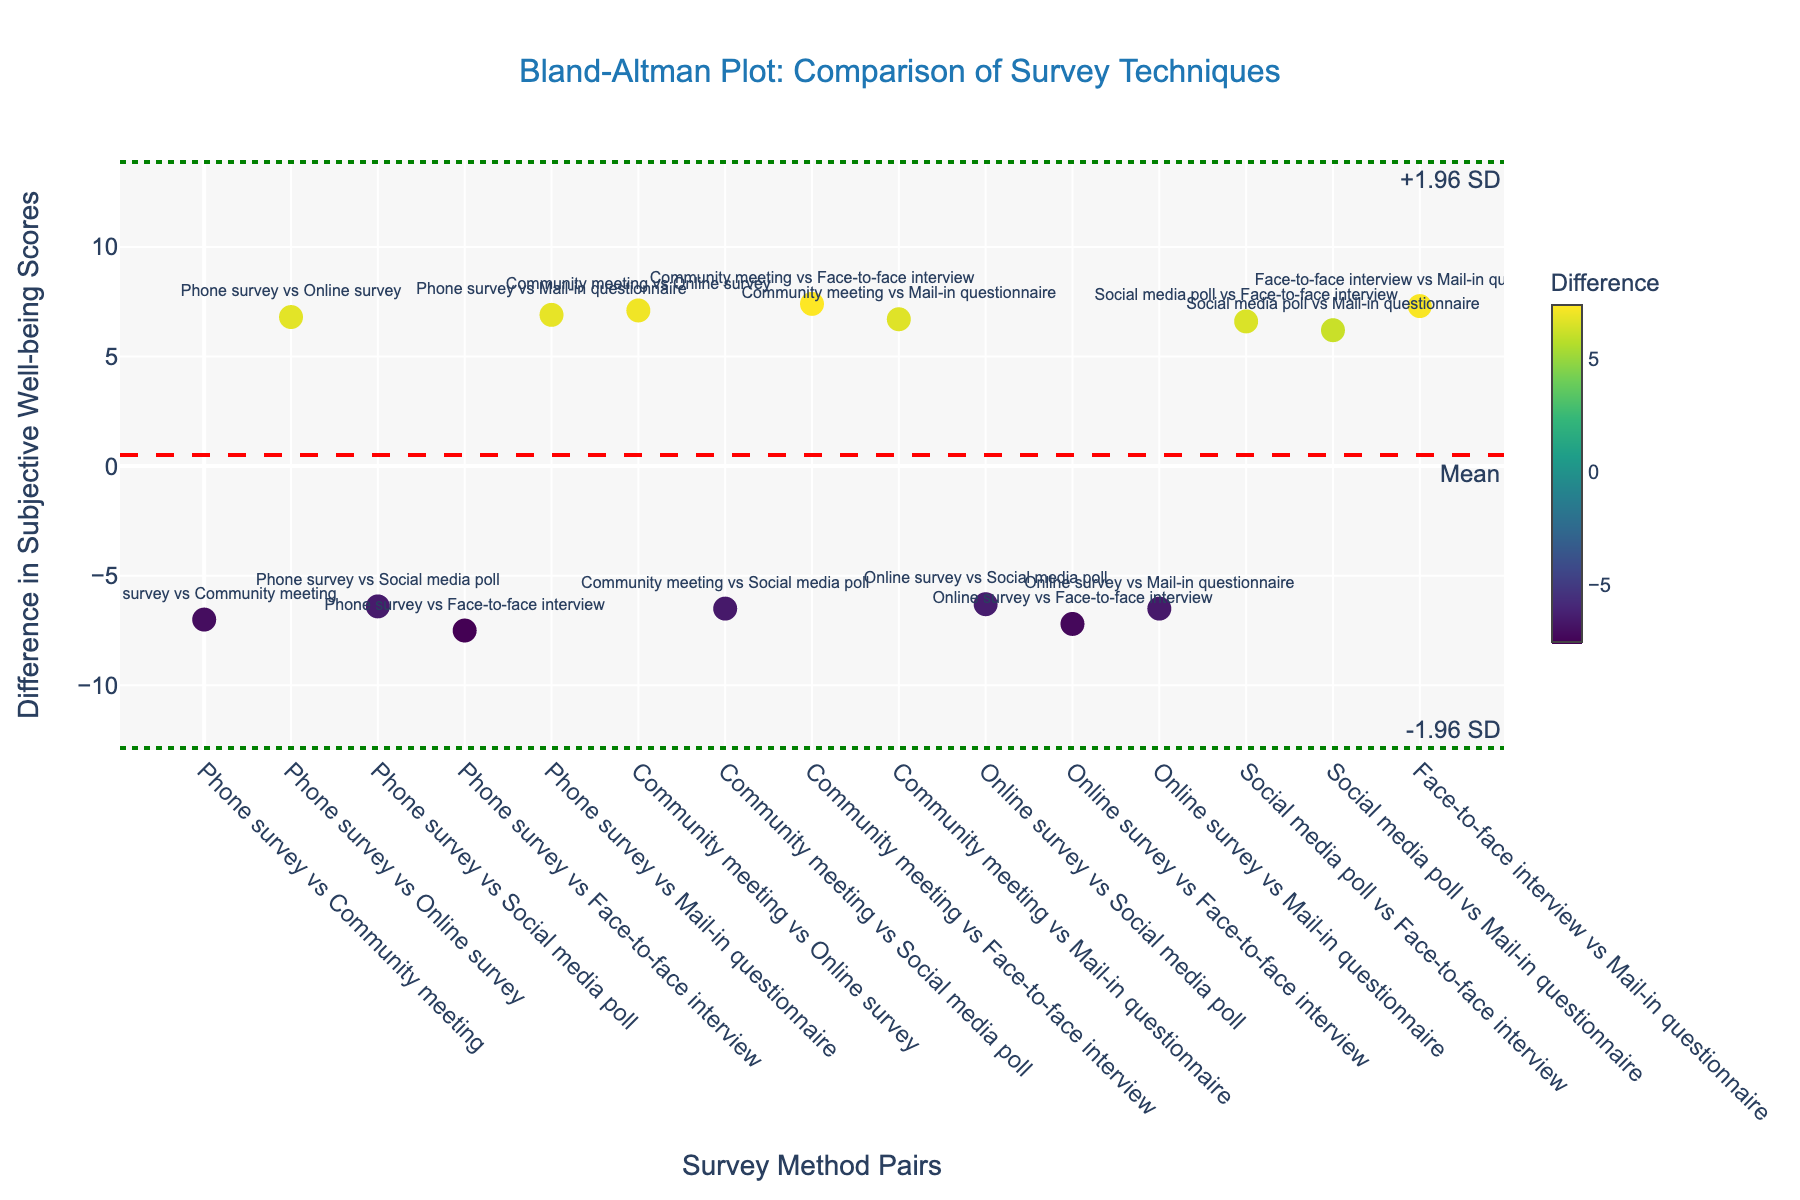What is the title of the plot? The title is usually displayed at the top of the plot, centered. In this case, it reads "Bland-Altman Plot: Comparison of Survey Techniques".
Answer: Bland-Altman Plot: Comparison of Survey Techniques What is displayed on the y-axis? The label on the y-axis indicates what is being measured. The y-axis label in this plot is "Difference in Subjective Well-being Scores".
Answer: Difference in Subjective Well-being Scores How many survey method pairs are compared in the plot? To determine the number of survey method pairs, count the number of points along the x-axis, where each tick represents a pair.
Answer: 10 Which pair has the highest difference in subjective well-being scores? By observing the y-axis values for each data point, the pair with the highest y-axis value corresponds to the highest difference.
Answer: Face-to-face interview vs Phone survey What is the mean difference in subjective well-being scores? The mean difference is shown by the red dashed line annotated with "Mean".
Answer: Approximately 0.24 Which survey method pair shows the least difference in subjective well-being scores? Identify the point on the plot with the lowest y-axis value, which will correspond to the pair with the smallest difference.
Answer: Social media poll vs Mail-in questionnaire What is the approximate value of the upper 1.96 standard deviation limit? The upper 1.96 standard deviation limit is shown by the green dotted line annotated with "+1.96 SD".
Answer: Approximately 0.8 What is the difference between the highest and lowest difference values in the plot? Identify the highest and lowest y-values, then subtract the lowest value from the highest to find the difference.
Answer: The highest difference is approximately 0.7 (Face-to-face interview vs Phone survey), and the lowest is around -0.1 (Social media poll vs Mail-in questionnaire), so the difference is about 0.8 Are there any survey method pairs that have a negative difference? Check for any data points that are below the y-axis value of zero; these indicate negative differences.
Answer: Yes Which survey method pairs are within one standard deviation from the mean difference? Calculate the range within one standard deviation from the mean difference (mean_diff ± std_diff), then identify pairs whose differences fall within this range.
Answer: Values within approximately -0.1 to 0.58. Specific pairs need to be identified from the plot 